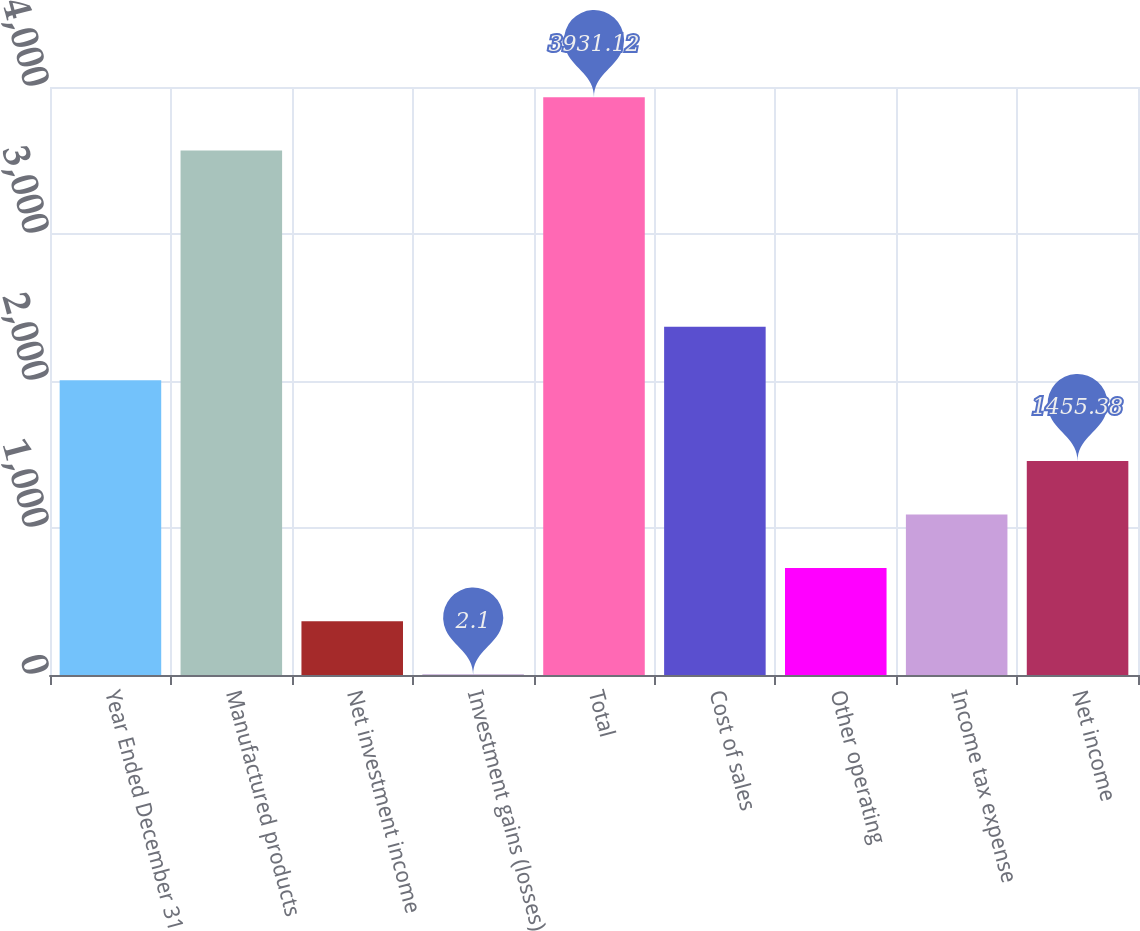<chart> <loc_0><loc_0><loc_500><loc_500><bar_chart><fcel>Year Ended December 31<fcel>Manufactured products<fcel>Net investment income<fcel>Investment gains (losses)<fcel>Total<fcel>Cost of sales<fcel>Other operating<fcel>Income tax expense<fcel>Net income<nl><fcel>2005<fcel>3567.8<fcel>365.42<fcel>2.1<fcel>3931.12<fcel>2368.32<fcel>728.74<fcel>1092.06<fcel>1455.38<nl></chart> 